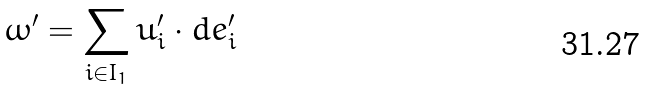Convert formula to latex. <formula><loc_0><loc_0><loc_500><loc_500>\omega ^ { \prime } = \sum _ { i \in I _ { 1 } } u _ { i } ^ { \prime } \cdot d e _ { i } ^ { \prime }</formula> 